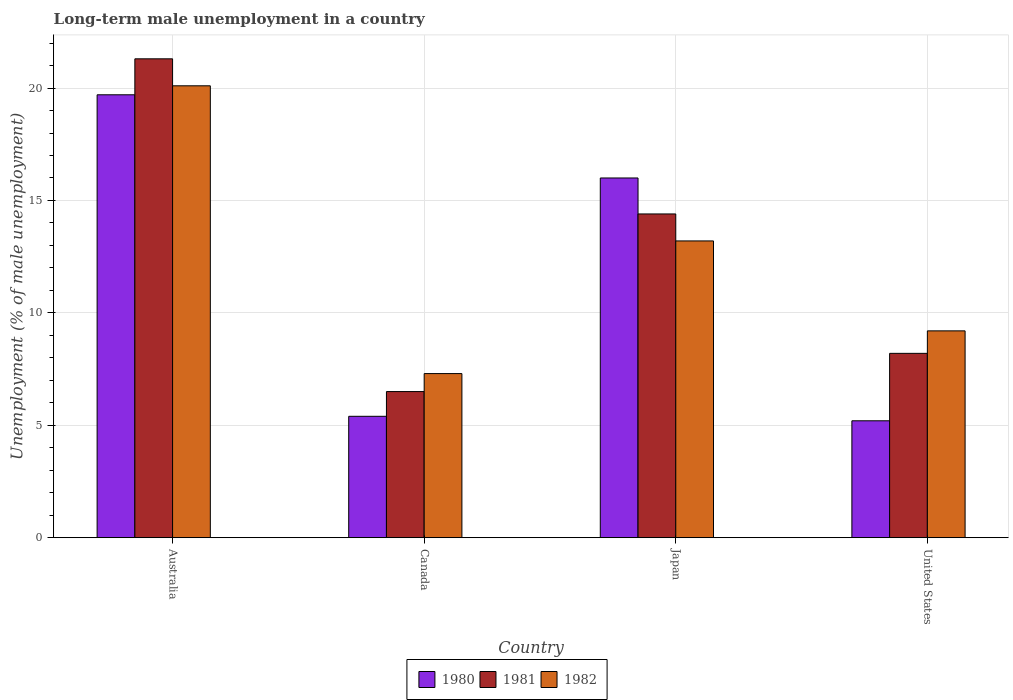How many different coloured bars are there?
Your answer should be compact. 3. How many groups of bars are there?
Give a very brief answer. 4. Are the number of bars per tick equal to the number of legend labels?
Offer a very short reply. Yes. How many bars are there on the 4th tick from the right?
Provide a short and direct response. 3. What is the label of the 4th group of bars from the left?
Make the answer very short. United States. What is the percentage of long-term unemployed male population in 1981 in Australia?
Provide a succinct answer. 21.3. Across all countries, what is the maximum percentage of long-term unemployed male population in 1981?
Make the answer very short. 21.3. Across all countries, what is the minimum percentage of long-term unemployed male population in 1981?
Give a very brief answer. 6.5. What is the total percentage of long-term unemployed male population in 1982 in the graph?
Ensure brevity in your answer.  49.8. What is the difference between the percentage of long-term unemployed male population in 1982 in Canada and that in United States?
Provide a short and direct response. -1.9. What is the difference between the percentage of long-term unemployed male population in 1981 in Australia and the percentage of long-term unemployed male population in 1980 in Canada?
Ensure brevity in your answer.  15.9. What is the average percentage of long-term unemployed male population in 1982 per country?
Give a very brief answer. 12.45. What is the difference between the percentage of long-term unemployed male population of/in 1980 and percentage of long-term unemployed male population of/in 1981 in Australia?
Offer a terse response. -1.6. What is the ratio of the percentage of long-term unemployed male population in 1980 in Australia to that in Canada?
Your answer should be compact. 3.65. Is the percentage of long-term unemployed male population in 1982 in Japan less than that in United States?
Offer a very short reply. No. What is the difference between the highest and the second highest percentage of long-term unemployed male population in 1980?
Your response must be concise. -3.7. What is the difference between the highest and the lowest percentage of long-term unemployed male population in 1981?
Offer a terse response. 14.8. In how many countries, is the percentage of long-term unemployed male population in 1982 greater than the average percentage of long-term unemployed male population in 1982 taken over all countries?
Ensure brevity in your answer.  2. Is the sum of the percentage of long-term unemployed male population in 1980 in Australia and United States greater than the maximum percentage of long-term unemployed male population in 1982 across all countries?
Provide a short and direct response. Yes. Is it the case that in every country, the sum of the percentage of long-term unemployed male population in 1980 and percentage of long-term unemployed male population in 1981 is greater than the percentage of long-term unemployed male population in 1982?
Offer a very short reply. Yes. How many bars are there?
Provide a short and direct response. 12. Are all the bars in the graph horizontal?
Offer a terse response. No. Are the values on the major ticks of Y-axis written in scientific E-notation?
Make the answer very short. No. How are the legend labels stacked?
Offer a very short reply. Horizontal. What is the title of the graph?
Give a very brief answer. Long-term male unemployment in a country. Does "1963" appear as one of the legend labels in the graph?
Your answer should be very brief. No. What is the label or title of the X-axis?
Your response must be concise. Country. What is the label or title of the Y-axis?
Your response must be concise. Unemployment (% of male unemployment). What is the Unemployment (% of male unemployment) in 1980 in Australia?
Give a very brief answer. 19.7. What is the Unemployment (% of male unemployment) of 1981 in Australia?
Provide a succinct answer. 21.3. What is the Unemployment (% of male unemployment) of 1982 in Australia?
Your answer should be compact. 20.1. What is the Unemployment (% of male unemployment) of 1980 in Canada?
Provide a succinct answer. 5.4. What is the Unemployment (% of male unemployment) of 1982 in Canada?
Your answer should be very brief. 7.3. What is the Unemployment (% of male unemployment) in 1980 in Japan?
Make the answer very short. 16. What is the Unemployment (% of male unemployment) of 1981 in Japan?
Ensure brevity in your answer.  14.4. What is the Unemployment (% of male unemployment) of 1982 in Japan?
Make the answer very short. 13.2. What is the Unemployment (% of male unemployment) of 1980 in United States?
Provide a succinct answer. 5.2. What is the Unemployment (% of male unemployment) in 1981 in United States?
Your response must be concise. 8.2. What is the Unemployment (% of male unemployment) of 1982 in United States?
Your response must be concise. 9.2. Across all countries, what is the maximum Unemployment (% of male unemployment) of 1980?
Offer a very short reply. 19.7. Across all countries, what is the maximum Unemployment (% of male unemployment) of 1981?
Provide a succinct answer. 21.3. Across all countries, what is the maximum Unemployment (% of male unemployment) in 1982?
Make the answer very short. 20.1. Across all countries, what is the minimum Unemployment (% of male unemployment) of 1980?
Keep it short and to the point. 5.2. Across all countries, what is the minimum Unemployment (% of male unemployment) in 1981?
Provide a short and direct response. 6.5. Across all countries, what is the minimum Unemployment (% of male unemployment) of 1982?
Provide a succinct answer. 7.3. What is the total Unemployment (% of male unemployment) of 1980 in the graph?
Make the answer very short. 46.3. What is the total Unemployment (% of male unemployment) in 1981 in the graph?
Provide a succinct answer. 50.4. What is the total Unemployment (% of male unemployment) of 1982 in the graph?
Your answer should be very brief. 49.8. What is the difference between the Unemployment (% of male unemployment) in 1981 in Australia and that in Japan?
Your answer should be very brief. 6.9. What is the difference between the Unemployment (% of male unemployment) in 1981 in Australia and that in United States?
Your answer should be compact. 13.1. What is the difference between the Unemployment (% of male unemployment) of 1982 in Australia and that in United States?
Provide a succinct answer. 10.9. What is the difference between the Unemployment (% of male unemployment) of 1981 in Canada and that in Japan?
Your response must be concise. -7.9. What is the difference between the Unemployment (% of male unemployment) of 1982 in Canada and that in Japan?
Give a very brief answer. -5.9. What is the difference between the Unemployment (% of male unemployment) of 1980 in Japan and that in United States?
Offer a terse response. 10.8. What is the difference between the Unemployment (% of male unemployment) of 1981 in Australia and the Unemployment (% of male unemployment) of 1982 in Canada?
Offer a terse response. 14. What is the difference between the Unemployment (% of male unemployment) of 1980 in Australia and the Unemployment (% of male unemployment) of 1981 in Japan?
Make the answer very short. 5.3. What is the difference between the Unemployment (% of male unemployment) of 1980 in Australia and the Unemployment (% of male unemployment) of 1982 in Japan?
Give a very brief answer. 6.5. What is the difference between the Unemployment (% of male unemployment) of 1981 in Australia and the Unemployment (% of male unemployment) of 1982 in Japan?
Your answer should be compact. 8.1. What is the difference between the Unemployment (% of male unemployment) of 1981 in Australia and the Unemployment (% of male unemployment) of 1982 in United States?
Provide a succinct answer. 12.1. What is the difference between the Unemployment (% of male unemployment) of 1980 in Canada and the Unemployment (% of male unemployment) of 1981 in Japan?
Your response must be concise. -9. What is the difference between the Unemployment (% of male unemployment) in 1980 in Canada and the Unemployment (% of male unemployment) in 1982 in Japan?
Your answer should be compact. -7.8. What is the difference between the Unemployment (% of male unemployment) of 1981 in Canada and the Unemployment (% of male unemployment) of 1982 in United States?
Keep it short and to the point. -2.7. What is the average Unemployment (% of male unemployment) in 1980 per country?
Keep it short and to the point. 11.57. What is the average Unemployment (% of male unemployment) of 1982 per country?
Give a very brief answer. 12.45. What is the difference between the Unemployment (% of male unemployment) in 1980 and Unemployment (% of male unemployment) in 1981 in Australia?
Offer a terse response. -1.6. What is the difference between the Unemployment (% of male unemployment) in 1980 and Unemployment (% of male unemployment) in 1982 in Australia?
Keep it short and to the point. -0.4. What is the difference between the Unemployment (% of male unemployment) in 1981 and Unemployment (% of male unemployment) in 1982 in Australia?
Make the answer very short. 1.2. What is the difference between the Unemployment (% of male unemployment) in 1980 and Unemployment (% of male unemployment) in 1981 in Canada?
Offer a very short reply. -1.1. What is the difference between the Unemployment (% of male unemployment) of 1980 and Unemployment (% of male unemployment) of 1982 in Canada?
Your answer should be compact. -1.9. What is the difference between the Unemployment (% of male unemployment) of 1980 and Unemployment (% of male unemployment) of 1981 in Japan?
Keep it short and to the point. 1.6. What is the difference between the Unemployment (% of male unemployment) of 1980 and Unemployment (% of male unemployment) of 1982 in Japan?
Provide a short and direct response. 2.8. What is the ratio of the Unemployment (% of male unemployment) of 1980 in Australia to that in Canada?
Give a very brief answer. 3.65. What is the ratio of the Unemployment (% of male unemployment) in 1981 in Australia to that in Canada?
Give a very brief answer. 3.28. What is the ratio of the Unemployment (% of male unemployment) in 1982 in Australia to that in Canada?
Give a very brief answer. 2.75. What is the ratio of the Unemployment (% of male unemployment) of 1980 in Australia to that in Japan?
Keep it short and to the point. 1.23. What is the ratio of the Unemployment (% of male unemployment) of 1981 in Australia to that in Japan?
Offer a very short reply. 1.48. What is the ratio of the Unemployment (% of male unemployment) of 1982 in Australia to that in Japan?
Give a very brief answer. 1.52. What is the ratio of the Unemployment (% of male unemployment) of 1980 in Australia to that in United States?
Offer a very short reply. 3.79. What is the ratio of the Unemployment (% of male unemployment) of 1981 in Australia to that in United States?
Your response must be concise. 2.6. What is the ratio of the Unemployment (% of male unemployment) of 1982 in Australia to that in United States?
Your answer should be compact. 2.18. What is the ratio of the Unemployment (% of male unemployment) in 1980 in Canada to that in Japan?
Your answer should be compact. 0.34. What is the ratio of the Unemployment (% of male unemployment) of 1981 in Canada to that in Japan?
Your response must be concise. 0.45. What is the ratio of the Unemployment (% of male unemployment) in 1982 in Canada to that in Japan?
Ensure brevity in your answer.  0.55. What is the ratio of the Unemployment (% of male unemployment) in 1981 in Canada to that in United States?
Keep it short and to the point. 0.79. What is the ratio of the Unemployment (% of male unemployment) in 1982 in Canada to that in United States?
Your answer should be compact. 0.79. What is the ratio of the Unemployment (% of male unemployment) in 1980 in Japan to that in United States?
Keep it short and to the point. 3.08. What is the ratio of the Unemployment (% of male unemployment) in 1981 in Japan to that in United States?
Make the answer very short. 1.76. What is the ratio of the Unemployment (% of male unemployment) of 1982 in Japan to that in United States?
Your answer should be compact. 1.43. What is the difference between the highest and the second highest Unemployment (% of male unemployment) in 1980?
Keep it short and to the point. 3.7. What is the difference between the highest and the lowest Unemployment (% of male unemployment) in 1981?
Offer a terse response. 14.8. 